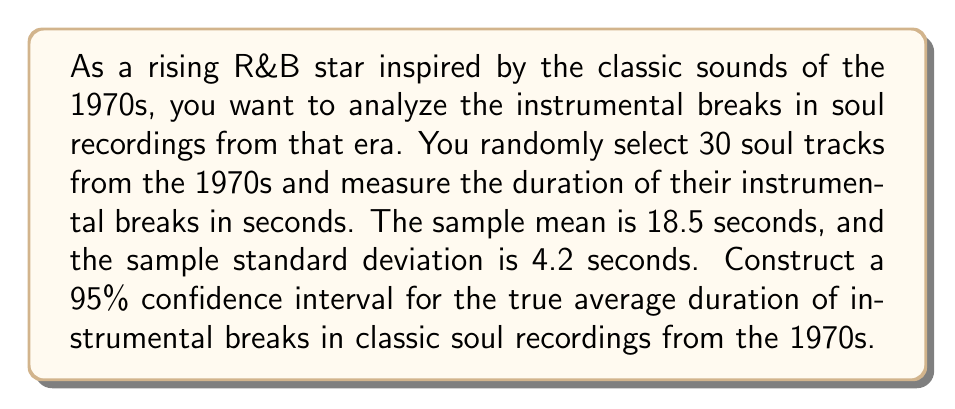Could you help me with this problem? To construct a 95% confidence interval for the population mean, we'll use the t-distribution since we don't know the population standard deviation and our sample size is less than 30. Here's the step-by-step process:

1. Identify the given information:
   - Sample size: $n = 30$
   - Sample mean: $\bar{x} = 18.5$ seconds
   - Sample standard deviation: $s = 4.2$ seconds
   - Confidence level: 95% (α = 0.05)

2. Determine the degrees of freedom:
   $df = n - 1 = 30 - 1 = 29$

3. Find the critical t-value for a 95% confidence interval with 29 degrees of freedom:
   $t_{0.025, 29} = 2.045$ (from t-distribution table)

4. Calculate the standard error of the mean:
   $SE = \frac{s}{\sqrt{n}} = \frac{4.2}{\sqrt{30}} = 0.7669$

5. Compute the margin of error:
   $ME = t_{0.025, 29} \cdot SE = 2.045 \cdot 0.7669 = 1.5683$

6. Construct the confidence interval:
   $CI = \bar{x} \pm ME$
   $CI = 18.5 \pm 1.5683$
   $CI = (16.9317, 20.0683)$

Therefore, we can be 95% confident that the true average duration of instrumental breaks in classic soul recordings from the 1970s falls between 16.9317 and 20.0683 seconds.
Answer: The 95% confidence interval for the true average duration of instrumental breaks in classic soul recordings from the 1970s is (16.9317, 20.0683) seconds. 